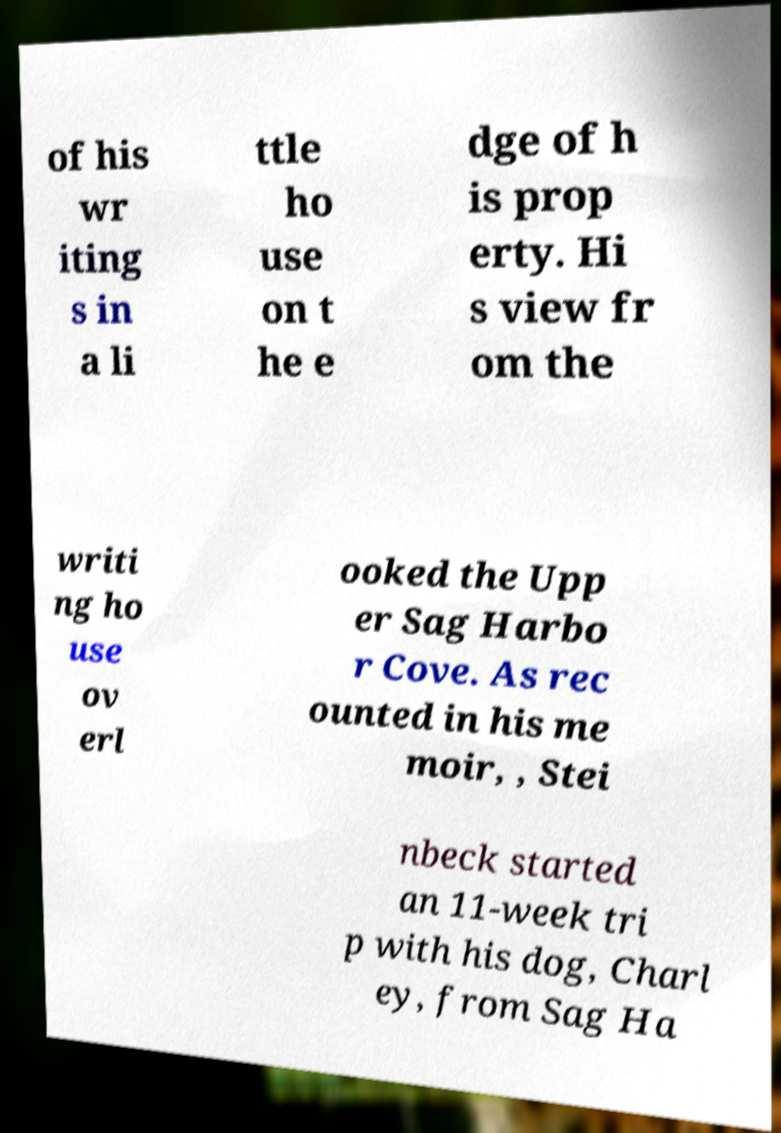What messages or text are displayed in this image? I need them in a readable, typed format. of his wr iting s in a li ttle ho use on t he e dge of h is prop erty. Hi s view fr om the writi ng ho use ov erl ooked the Upp er Sag Harbo r Cove. As rec ounted in his me moir, , Stei nbeck started an 11-week tri p with his dog, Charl ey, from Sag Ha 